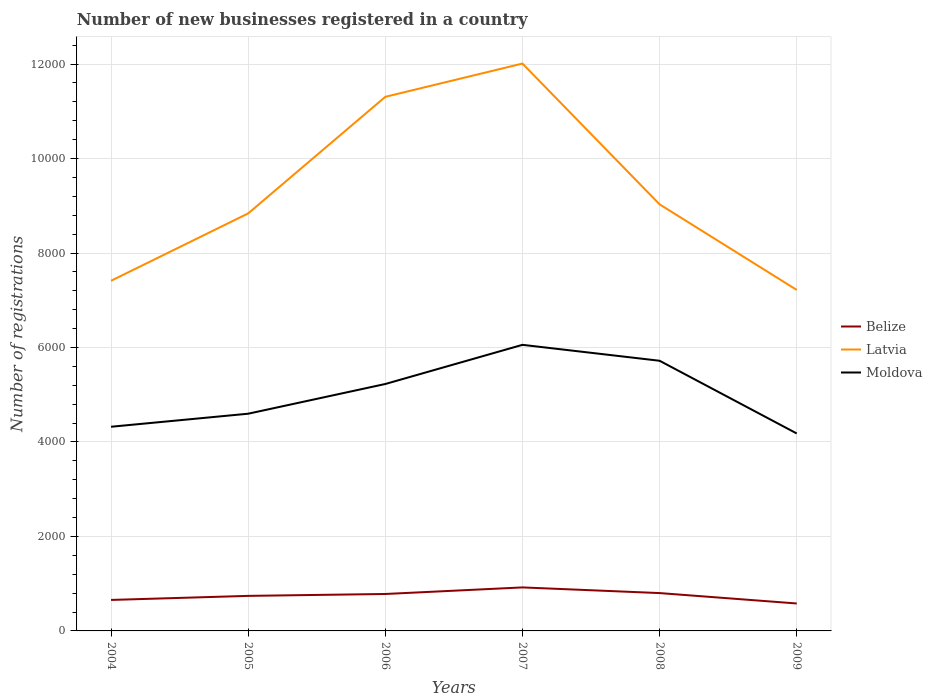Does the line corresponding to Latvia intersect with the line corresponding to Moldova?
Offer a terse response. No. Across all years, what is the maximum number of new businesses registered in Latvia?
Your answer should be compact. 7218. What is the total number of new businesses registered in Latvia in the graph?
Provide a short and direct response. 4088. What is the difference between the highest and the second highest number of new businesses registered in Moldova?
Offer a terse response. 1876. How many years are there in the graph?
Make the answer very short. 6. Are the values on the major ticks of Y-axis written in scientific E-notation?
Give a very brief answer. No. Does the graph contain any zero values?
Keep it short and to the point. No. How many legend labels are there?
Your answer should be very brief. 3. How are the legend labels stacked?
Ensure brevity in your answer.  Vertical. What is the title of the graph?
Make the answer very short. Number of new businesses registered in a country. What is the label or title of the Y-axis?
Ensure brevity in your answer.  Number of registrations. What is the Number of registrations in Belize in 2004?
Offer a very short reply. 656. What is the Number of registrations in Latvia in 2004?
Provide a succinct answer. 7412. What is the Number of registrations of Moldova in 2004?
Keep it short and to the point. 4322. What is the Number of registrations of Belize in 2005?
Your answer should be compact. 742. What is the Number of registrations in Latvia in 2005?
Make the answer very short. 8838. What is the Number of registrations in Moldova in 2005?
Offer a very short reply. 4598. What is the Number of registrations in Belize in 2006?
Keep it short and to the point. 782. What is the Number of registrations in Latvia in 2006?
Make the answer very short. 1.13e+04. What is the Number of registrations in Moldova in 2006?
Ensure brevity in your answer.  5227. What is the Number of registrations in Belize in 2007?
Provide a succinct answer. 921. What is the Number of registrations in Latvia in 2007?
Your answer should be compact. 1.20e+04. What is the Number of registrations in Moldova in 2007?
Keep it short and to the point. 6056. What is the Number of registrations in Belize in 2008?
Offer a very short reply. 801. What is the Number of registrations in Latvia in 2008?
Your answer should be compact. 9030. What is the Number of registrations in Moldova in 2008?
Ensure brevity in your answer.  5719. What is the Number of registrations in Belize in 2009?
Provide a short and direct response. 581. What is the Number of registrations of Latvia in 2009?
Your answer should be very brief. 7218. What is the Number of registrations of Moldova in 2009?
Your response must be concise. 4180. Across all years, what is the maximum Number of registrations in Belize?
Make the answer very short. 921. Across all years, what is the maximum Number of registrations in Latvia?
Provide a succinct answer. 1.20e+04. Across all years, what is the maximum Number of registrations of Moldova?
Your answer should be compact. 6056. Across all years, what is the minimum Number of registrations of Belize?
Your response must be concise. 581. Across all years, what is the minimum Number of registrations of Latvia?
Provide a short and direct response. 7218. Across all years, what is the minimum Number of registrations of Moldova?
Make the answer very short. 4180. What is the total Number of registrations in Belize in the graph?
Give a very brief answer. 4483. What is the total Number of registrations in Latvia in the graph?
Offer a very short reply. 5.58e+04. What is the total Number of registrations of Moldova in the graph?
Provide a short and direct response. 3.01e+04. What is the difference between the Number of registrations of Belize in 2004 and that in 2005?
Your answer should be very brief. -86. What is the difference between the Number of registrations of Latvia in 2004 and that in 2005?
Give a very brief answer. -1426. What is the difference between the Number of registrations of Moldova in 2004 and that in 2005?
Your answer should be compact. -276. What is the difference between the Number of registrations of Belize in 2004 and that in 2006?
Offer a terse response. -126. What is the difference between the Number of registrations in Latvia in 2004 and that in 2006?
Keep it short and to the point. -3894. What is the difference between the Number of registrations in Moldova in 2004 and that in 2006?
Ensure brevity in your answer.  -905. What is the difference between the Number of registrations in Belize in 2004 and that in 2007?
Ensure brevity in your answer.  -265. What is the difference between the Number of registrations in Latvia in 2004 and that in 2007?
Your answer should be very brief. -4598. What is the difference between the Number of registrations of Moldova in 2004 and that in 2007?
Provide a short and direct response. -1734. What is the difference between the Number of registrations in Belize in 2004 and that in 2008?
Ensure brevity in your answer.  -145. What is the difference between the Number of registrations in Latvia in 2004 and that in 2008?
Make the answer very short. -1618. What is the difference between the Number of registrations in Moldova in 2004 and that in 2008?
Your answer should be compact. -1397. What is the difference between the Number of registrations in Belize in 2004 and that in 2009?
Keep it short and to the point. 75. What is the difference between the Number of registrations of Latvia in 2004 and that in 2009?
Offer a very short reply. 194. What is the difference between the Number of registrations of Moldova in 2004 and that in 2009?
Offer a terse response. 142. What is the difference between the Number of registrations in Latvia in 2005 and that in 2006?
Ensure brevity in your answer.  -2468. What is the difference between the Number of registrations of Moldova in 2005 and that in 2006?
Provide a succinct answer. -629. What is the difference between the Number of registrations in Belize in 2005 and that in 2007?
Your answer should be very brief. -179. What is the difference between the Number of registrations of Latvia in 2005 and that in 2007?
Provide a succinct answer. -3172. What is the difference between the Number of registrations of Moldova in 2005 and that in 2007?
Give a very brief answer. -1458. What is the difference between the Number of registrations of Belize in 2005 and that in 2008?
Give a very brief answer. -59. What is the difference between the Number of registrations of Latvia in 2005 and that in 2008?
Offer a terse response. -192. What is the difference between the Number of registrations in Moldova in 2005 and that in 2008?
Offer a terse response. -1121. What is the difference between the Number of registrations of Belize in 2005 and that in 2009?
Keep it short and to the point. 161. What is the difference between the Number of registrations in Latvia in 2005 and that in 2009?
Offer a very short reply. 1620. What is the difference between the Number of registrations of Moldova in 2005 and that in 2009?
Your answer should be compact. 418. What is the difference between the Number of registrations of Belize in 2006 and that in 2007?
Offer a very short reply. -139. What is the difference between the Number of registrations of Latvia in 2006 and that in 2007?
Your answer should be compact. -704. What is the difference between the Number of registrations in Moldova in 2006 and that in 2007?
Your response must be concise. -829. What is the difference between the Number of registrations of Belize in 2006 and that in 2008?
Offer a very short reply. -19. What is the difference between the Number of registrations in Latvia in 2006 and that in 2008?
Keep it short and to the point. 2276. What is the difference between the Number of registrations of Moldova in 2006 and that in 2008?
Ensure brevity in your answer.  -492. What is the difference between the Number of registrations of Belize in 2006 and that in 2009?
Offer a terse response. 201. What is the difference between the Number of registrations in Latvia in 2006 and that in 2009?
Ensure brevity in your answer.  4088. What is the difference between the Number of registrations of Moldova in 2006 and that in 2009?
Offer a very short reply. 1047. What is the difference between the Number of registrations of Belize in 2007 and that in 2008?
Your answer should be compact. 120. What is the difference between the Number of registrations in Latvia in 2007 and that in 2008?
Give a very brief answer. 2980. What is the difference between the Number of registrations in Moldova in 2007 and that in 2008?
Provide a succinct answer. 337. What is the difference between the Number of registrations of Belize in 2007 and that in 2009?
Ensure brevity in your answer.  340. What is the difference between the Number of registrations of Latvia in 2007 and that in 2009?
Make the answer very short. 4792. What is the difference between the Number of registrations of Moldova in 2007 and that in 2009?
Offer a terse response. 1876. What is the difference between the Number of registrations in Belize in 2008 and that in 2009?
Your answer should be compact. 220. What is the difference between the Number of registrations of Latvia in 2008 and that in 2009?
Provide a short and direct response. 1812. What is the difference between the Number of registrations of Moldova in 2008 and that in 2009?
Ensure brevity in your answer.  1539. What is the difference between the Number of registrations of Belize in 2004 and the Number of registrations of Latvia in 2005?
Make the answer very short. -8182. What is the difference between the Number of registrations of Belize in 2004 and the Number of registrations of Moldova in 2005?
Your response must be concise. -3942. What is the difference between the Number of registrations in Latvia in 2004 and the Number of registrations in Moldova in 2005?
Give a very brief answer. 2814. What is the difference between the Number of registrations in Belize in 2004 and the Number of registrations in Latvia in 2006?
Make the answer very short. -1.06e+04. What is the difference between the Number of registrations of Belize in 2004 and the Number of registrations of Moldova in 2006?
Your response must be concise. -4571. What is the difference between the Number of registrations of Latvia in 2004 and the Number of registrations of Moldova in 2006?
Give a very brief answer. 2185. What is the difference between the Number of registrations of Belize in 2004 and the Number of registrations of Latvia in 2007?
Your answer should be compact. -1.14e+04. What is the difference between the Number of registrations in Belize in 2004 and the Number of registrations in Moldova in 2007?
Provide a short and direct response. -5400. What is the difference between the Number of registrations in Latvia in 2004 and the Number of registrations in Moldova in 2007?
Ensure brevity in your answer.  1356. What is the difference between the Number of registrations of Belize in 2004 and the Number of registrations of Latvia in 2008?
Make the answer very short. -8374. What is the difference between the Number of registrations of Belize in 2004 and the Number of registrations of Moldova in 2008?
Keep it short and to the point. -5063. What is the difference between the Number of registrations of Latvia in 2004 and the Number of registrations of Moldova in 2008?
Provide a short and direct response. 1693. What is the difference between the Number of registrations in Belize in 2004 and the Number of registrations in Latvia in 2009?
Give a very brief answer. -6562. What is the difference between the Number of registrations in Belize in 2004 and the Number of registrations in Moldova in 2009?
Offer a very short reply. -3524. What is the difference between the Number of registrations in Latvia in 2004 and the Number of registrations in Moldova in 2009?
Give a very brief answer. 3232. What is the difference between the Number of registrations in Belize in 2005 and the Number of registrations in Latvia in 2006?
Provide a short and direct response. -1.06e+04. What is the difference between the Number of registrations of Belize in 2005 and the Number of registrations of Moldova in 2006?
Offer a very short reply. -4485. What is the difference between the Number of registrations in Latvia in 2005 and the Number of registrations in Moldova in 2006?
Make the answer very short. 3611. What is the difference between the Number of registrations in Belize in 2005 and the Number of registrations in Latvia in 2007?
Your answer should be compact. -1.13e+04. What is the difference between the Number of registrations of Belize in 2005 and the Number of registrations of Moldova in 2007?
Keep it short and to the point. -5314. What is the difference between the Number of registrations in Latvia in 2005 and the Number of registrations in Moldova in 2007?
Give a very brief answer. 2782. What is the difference between the Number of registrations in Belize in 2005 and the Number of registrations in Latvia in 2008?
Give a very brief answer. -8288. What is the difference between the Number of registrations in Belize in 2005 and the Number of registrations in Moldova in 2008?
Your answer should be very brief. -4977. What is the difference between the Number of registrations in Latvia in 2005 and the Number of registrations in Moldova in 2008?
Ensure brevity in your answer.  3119. What is the difference between the Number of registrations in Belize in 2005 and the Number of registrations in Latvia in 2009?
Offer a terse response. -6476. What is the difference between the Number of registrations of Belize in 2005 and the Number of registrations of Moldova in 2009?
Offer a very short reply. -3438. What is the difference between the Number of registrations of Latvia in 2005 and the Number of registrations of Moldova in 2009?
Your answer should be compact. 4658. What is the difference between the Number of registrations in Belize in 2006 and the Number of registrations in Latvia in 2007?
Provide a short and direct response. -1.12e+04. What is the difference between the Number of registrations in Belize in 2006 and the Number of registrations in Moldova in 2007?
Ensure brevity in your answer.  -5274. What is the difference between the Number of registrations of Latvia in 2006 and the Number of registrations of Moldova in 2007?
Your response must be concise. 5250. What is the difference between the Number of registrations in Belize in 2006 and the Number of registrations in Latvia in 2008?
Your response must be concise. -8248. What is the difference between the Number of registrations of Belize in 2006 and the Number of registrations of Moldova in 2008?
Your answer should be very brief. -4937. What is the difference between the Number of registrations in Latvia in 2006 and the Number of registrations in Moldova in 2008?
Provide a succinct answer. 5587. What is the difference between the Number of registrations of Belize in 2006 and the Number of registrations of Latvia in 2009?
Your answer should be compact. -6436. What is the difference between the Number of registrations of Belize in 2006 and the Number of registrations of Moldova in 2009?
Give a very brief answer. -3398. What is the difference between the Number of registrations in Latvia in 2006 and the Number of registrations in Moldova in 2009?
Your answer should be very brief. 7126. What is the difference between the Number of registrations of Belize in 2007 and the Number of registrations of Latvia in 2008?
Ensure brevity in your answer.  -8109. What is the difference between the Number of registrations in Belize in 2007 and the Number of registrations in Moldova in 2008?
Give a very brief answer. -4798. What is the difference between the Number of registrations in Latvia in 2007 and the Number of registrations in Moldova in 2008?
Offer a very short reply. 6291. What is the difference between the Number of registrations in Belize in 2007 and the Number of registrations in Latvia in 2009?
Your response must be concise. -6297. What is the difference between the Number of registrations of Belize in 2007 and the Number of registrations of Moldova in 2009?
Your answer should be very brief. -3259. What is the difference between the Number of registrations in Latvia in 2007 and the Number of registrations in Moldova in 2009?
Provide a short and direct response. 7830. What is the difference between the Number of registrations in Belize in 2008 and the Number of registrations in Latvia in 2009?
Give a very brief answer. -6417. What is the difference between the Number of registrations of Belize in 2008 and the Number of registrations of Moldova in 2009?
Give a very brief answer. -3379. What is the difference between the Number of registrations in Latvia in 2008 and the Number of registrations in Moldova in 2009?
Ensure brevity in your answer.  4850. What is the average Number of registrations of Belize per year?
Offer a terse response. 747.17. What is the average Number of registrations of Latvia per year?
Provide a succinct answer. 9302.33. What is the average Number of registrations of Moldova per year?
Make the answer very short. 5017. In the year 2004, what is the difference between the Number of registrations of Belize and Number of registrations of Latvia?
Your answer should be very brief. -6756. In the year 2004, what is the difference between the Number of registrations in Belize and Number of registrations in Moldova?
Give a very brief answer. -3666. In the year 2004, what is the difference between the Number of registrations in Latvia and Number of registrations in Moldova?
Provide a succinct answer. 3090. In the year 2005, what is the difference between the Number of registrations of Belize and Number of registrations of Latvia?
Give a very brief answer. -8096. In the year 2005, what is the difference between the Number of registrations in Belize and Number of registrations in Moldova?
Provide a succinct answer. -3856. In the year 2005, what is the difference between the Number of registrations of Latvia and Number of registrations of Moldova?
Your answer should be compact. 4240. In the year 2006, what is the difference between the Number of registrations in Belize and Number of registrations in Latvia?
Ensure brevity in your answer.  -1.05e+04. In the year 2006, what is the difference between the Number of registrations of Belize and Number of registrations of Moldova?
Ensure brevity in your answer.  -4445. In the year 2006, what is the difference between the Number of registrations of Latvia and Number of registrations of Moldova?
Offer a very short reply. 6079. In the year 2007, what is the difference between the Number of registrations in Belize and Number of registrations in Latvia?
Keep it short and to the point. -1.11e+04. In the year 2007, what is the difference between the Number of registrations of Belize and Number of registrations of Moldova?
Your answer should be compact. -5135. In the year 2007, what is the difference between the Number of registrations of Latvia and Number of registrations of Moldova?
Provide a short and direct response. 5954. In the year 2008, what is the difference between the Number of registrations of Belize and Number of registrations of Latvia?
Make the answer very short. -8229. In the year 2008, what is the difference between the Number of registrations of Belize and Number of registrations of Moldova?
Make the answer very short. -4918. In the year 2008, what is the difference between the Number of registrations of Latvia and Number of registrations of Moldova?
Provide a short and direct response. 3311. In the year 2009, what is the difference between the Number of registrations of Belize and Number of registrations of Latvia?
Offer a terse response. -6637. In the year 2009, what is the difference between the Number of registrations of Belize and Number of registrations of Moldova?
Ensure brevity in your answer.  -3599. In the year 2009, what is the difference between the Number of registrations of Latvia and Number of registrations of Moldova?
Keep it short and to the point. 3038. What is the ratio of the Number of registrations in Belize in 2004 to that in 2005?
Your answer should be compact. 0.88. What is the ratio of the Number of registrations in Latvia in 2004 to that in 2005?
Provide a succinct answer. 0.84. What is the ratio of the Number of registrations of Moldova in 2004 to that in 2005?
Offer a terse response. 0.94. What is the ratio of the Number of registrations of Belize in 2004 to that in 2006?
Your answer should be compact. 0.84. What is the ratio of the Number of registrations of Latvia in 2004 to that in 2006?
Your answer should be compact. 0.66. What is the ratio of the Number of registrations in Moldova in 2004 to that in 2006?
Make the answer very short. 0.83. What is the ratio of the Number of registrations in Belize in 2004 to that in 2007?
Your answer should be very brief. 0.71. What is the ratio of the Number of registrations of Latvia in 2004 to that in 2007?
Provide a succinct answer. 0.62. What is the ratio of the Number of registrations of Moldova in 2004 to that in 2007?
Make the answer very short. 0.71. What is the ratio of the Number of registrations of Belize in 2004 to that in 2008?
Your answer should be very brief. 0.82. What is the ratio of the Number of registrations of Latvia in 2004 to that in 2008?
Your answer should be compact. 0.82. What is the ratio of the Number of registrations in Moldova in 2004 to that in 2008?
Provide a short and direct response. 0.76. What is the ratio of the Number of registrations in Belize in 2004 to that in 2009?
Your answer should be compact. 1.13. What is the ratio of the Number of registrations in Latvia in 2004 to that in 2009?
Offer a terse response. 1.03. What is the ratio of the Number of registrations of Moldova in 2004 to that in 2009?
Provide a succinct answer. 1.03. What is the ratio of the Number of registrations in Belize in 2005 to that in 2006?
Keep it short and to the point. 0.95. What is the ratio of the Number of registrations in Latvia in 2005 to that in 2006?
Give a very brief answer. 0.78. What is the ratio of the Number of registrations of Moldova in 2005 to that in 2006?
Give a very brief answer. 0.88. What is the ratio of the Number of registrations of Belize in 2005 to that in 2007?
Give a very brief answer. 0.81. What is the ratio of the Number of registrations of Latvia in 2005 to that in 2007?
Your answer should be compact. 0.74. What is the ratio of the Number of registrations of Moldova in 2005 to that in 2007?
Provide a short and direct response. 0.76. What is the ratio of the Number of registrations of Belize in 2005 to that in 2008?
Provide a succinct answer. 0.93. What is the ratio of the Number of registrations in Latvia in 2005 to that in 2008?
Offer a very short reply. 0.98. What is the ratio of the Number of registrations of Moldova in 2005 to that in 2008?
Ensure brevity in your answer.  0.8. What is the ratio of the Number of registrations in Belize in 2005 to that in 2009?
Offer a very short reply. 1.28. What is the ratio of the Number of registrations in Latvia in 2005 to that in 2009?
Ensure brevity in your answer.  1.22. What is the ratio of the Number of registrations in Belize in 2006 to that in 2007?
Make the answer very short. 0.85. What is the ratio of the Number of registrations in Latvia in 2006 to that in 2007?
Offer a terse response. 0.94. What is the ratio of the Number of registrations of Moldova in 2006 to that in 2007?
Provide a succinct answer. 0.86. What is the ratio of the Number of registrations in Belize in 2006 to that in 2008?
Your response must be concise. 0.98. What is the ratio of the Number of registrations of Latvia in 2006 to that in 2008?
Your response must be concise. 1.25. What is the ratio of the Number of registrations of Moldova in 2006 to that in 2008?
Your answer should be very brief. 0.91. What is the ratio of the Number of registrations in Belize in 2006 to that in 2009?
Provide a short and direct response. 1.35. What is the ratio of the Number of registrations in Latvia in 2006 to that in 2009?
Offer a very short reply. 1.57. What is the ratio of the Number of registrations of Moldova in 2006 to that in 2009?
Provide a short and direct response. 1.25. What is the ratio of the Number of registrations in Belize in 2007 to that in 2008?
Your response must be concise. 1.15. What is the ratio of the Number of registrations of Latvia in 2007 to that in 2008?
Make the answer very short. 1.33. What is the ratio of the Number of registrations in Moldova in 2007 to that in 2008?
Ensure brevity in your answer.  1.06. What is the ratio of the Number of registrations of Belize in 2007 to that in 2009?
Your answer should be very brief. 1.59. What is the ratio of the Number of registrations in Latvia in 2007 to that in 2009?
Offer a terse response. 1.66. What is the ratio of the Number of registrations in Moldova in 2007 to that in 2009?
Your answer should be very brief. 1.45. What is the ratio of the Number of registrations in Belize in 2008 to that in 2009?
Provide a short and direct response. 1.38. What is the ratio of the Number of registrations of Latvia in 2008 to that in 2009?
Provide a succinct answer. 1.25. What is the ratio of the Number of registrations of Moldova in 2008 to that in 2009?
Your response must be concise. 1.37. What is the difference between the highest and the second highest Number of registrations of Belize?
Your response must be concise. 120. What is the difference between the highest and the second highest Number of registrations in Latvia?
Your answer should be very brief. 704. What is the difference between the highest and the second highest Number of registrations in Moldova?
Ensure brevity in your answer.  337. What is the difference between the highest and the lowest Number of registrations in Belize?
Ensure brevity in your answer.  340. What is the difference between the highest and the lowest Number of registrations of Latvia?
Provide a short and direct response. 4792. What is the difference between the highest and the lowest Number of registrations of Moldova?
Keep it short and to the point. 1876. 